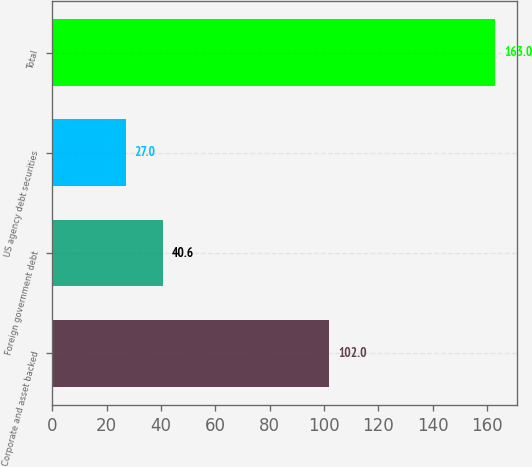Convert chart. <chart><loc_0><loc_0><loc_500><loc_500><bar_chart><fcel>Corporate and asset backed<fcel>Foreign government debt<fcel>US agency debt securities<fcel>Total<nl><fcel>102<fcel>40.6<fcel>27<fcel>163<nl></chart> 